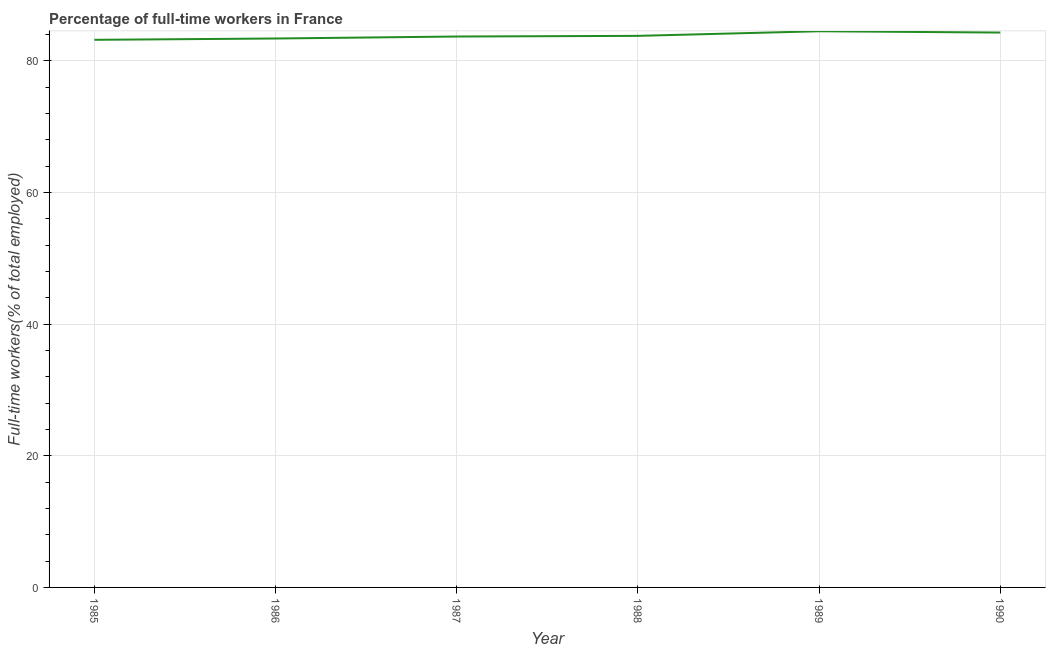What is the percentage of full-time workers in 1985?
Make the answer very short. 83.2. Across all years, what is the maximum percentage of full-time workers?
Offer a very short reply. 84.5. Across all years, what is the minimum percentage of full-time workers?
Your answer should be compact. 83.2. In which year was the percentage of full-time workers maximum?
Your answer should be compact. 1989. In which year was the percentage of full-time workers minimum?
Provide a succinct answer. 1985. What is the sum of the percentage of full-time workers?
Give a very brief answer. 502.9. What is the difference between the percentage of full-time workers in 1987 and 1990?
Your answer should be very brief. -0.6. What is the average percentage of full-time workers per year?
Your answer should be compact. 83.82. What is the median percentage of full-time workers?
Your answer should be very brief. 83.75. Do a majority of the years between 1990 and 1985 (inclusive) have percentage of full-time workers greater than 48 %?
Keep it short and to the point. Yes. What is the ratio of the percentage of full-time workers in 1986 to that in 1989?
Give a very brief answer. 0.99. Is the percentage of full-time workers in 1988 less than that in 1989?
Offer a very short reply. Yes. Is the difference between the percentage of full-time workers in 1986 and 1988 greater than the difference between any two years?
Your answer should be very brief. No. What is the difference between the highest and the second highest percentage of full-time workers?
Ensure brevity in your answer.  0.2. What is the difference between the highest and the lowest percentage of full-time workers?
Provide a succinct answer. 1.3. Does the percentage of full-time workers monotonically increase over the years?
Make the answer very short. No. How many lines are there?
Your answer should be compact. 1. How many years are there in the graph?
Offer a very short reply. 6. Are the values on the major ticks of Y-axis written in scientific E-notation?
Your response must be concise. No. Does the graph contain grids?
Ensure brevity in your answer.  Yes. What is the title of the graph?
Make the answer very short. Percentage of full-time workers in France. What is the label or title of the Y-axis?
Provide a succinct answer. Full-time workers(% of total employed). What is the Full-time workers(% of total employed) in 1985?
Ensure brevity in your answer.  83.2. What is the Full-time workers(% of total employed) in 1986?
Provide a short and direct response. 83.4. What is the Full-time workers(% of total employed) in 1987?
Keep it short and to the point. 83.7. What is the Full-time workers(% of total employed) in 1988?
Your answer should be very brief. 83.8. What is the Full-time workers(% of total employed) of 1989?
Keep it short and to the point. 84.5. What is the Full-time workers(% of total employed) in 1990?
Give a very brief answer. 84.3. What is the difference between the Full-time workers(% of total employed) in 1985 and 1986?
Keep it short and to the point. -0.2. What is the difference between the Full-time workers(% of total employed) in 1985 and 1987?
Your response must be concise. -0.5. What is the difference between the Full-time workers(% of total employed) in 1985 and 1988?
Your answer should be very brief. -0.6. What is the difference between the Full-time workers(% of total employed) in 1985 and 1990?
Provide a short and direct response. -1.1. What is the difference between the Full-time workers(% of total employed) in 1986 and 1989?
Offer a very short reply. -1.1. What is the difference between the Full-time workers(% of total employed) in 1987 and 1988?
Offer a terse response. -0.1. What is the difference between the Full-time workers(% of total employed) in 1987 and 1990?
Keep it short and to the point. -0.6. What is the difference between the Full-time workers(% of total employed) in 1989 and 1990?
Keep it short and to the point. 0.2. What is the ratio of the Full-time workers(% of total employed) in 1985 to that in 1986?
Give a very brief answer. 1. What is the ratio of the Full-time workers(% of total employed) in 1985 to that in 1988?
Provide a succinct answer. 0.99. What is the ratio of the Full-time workers(% of total employed) in 1985 to that in 1990?
Your answer should be very brief. 0.99. What is the ratio of the Full-time workers(% of total employed) in 1986 to that in 1988?
Make the answer very short. 0.99. What is the ratio of the Full-time workers(% of total employed) in 1986 to that in 1990?
Your response must be concise. 0.99. What is the ratio of the Full-time workers(% of total employed) in 1987 to that in 1988?
Provide a succinct answer. 1. What is the ratio of the Full-time workers(% of total employed) in 1987 to that in 1989?
Provide a succinct answer. 0.99. What is the ratio of the Full-time workers(% of total employed) in 1987 to that in 1990?
Ensure brevity in your answer.  0.99. What is the ratio of the Full-time workers(% of total employed) in 1988 to that in 1990?
Provide a short and direct response. 0.99. 